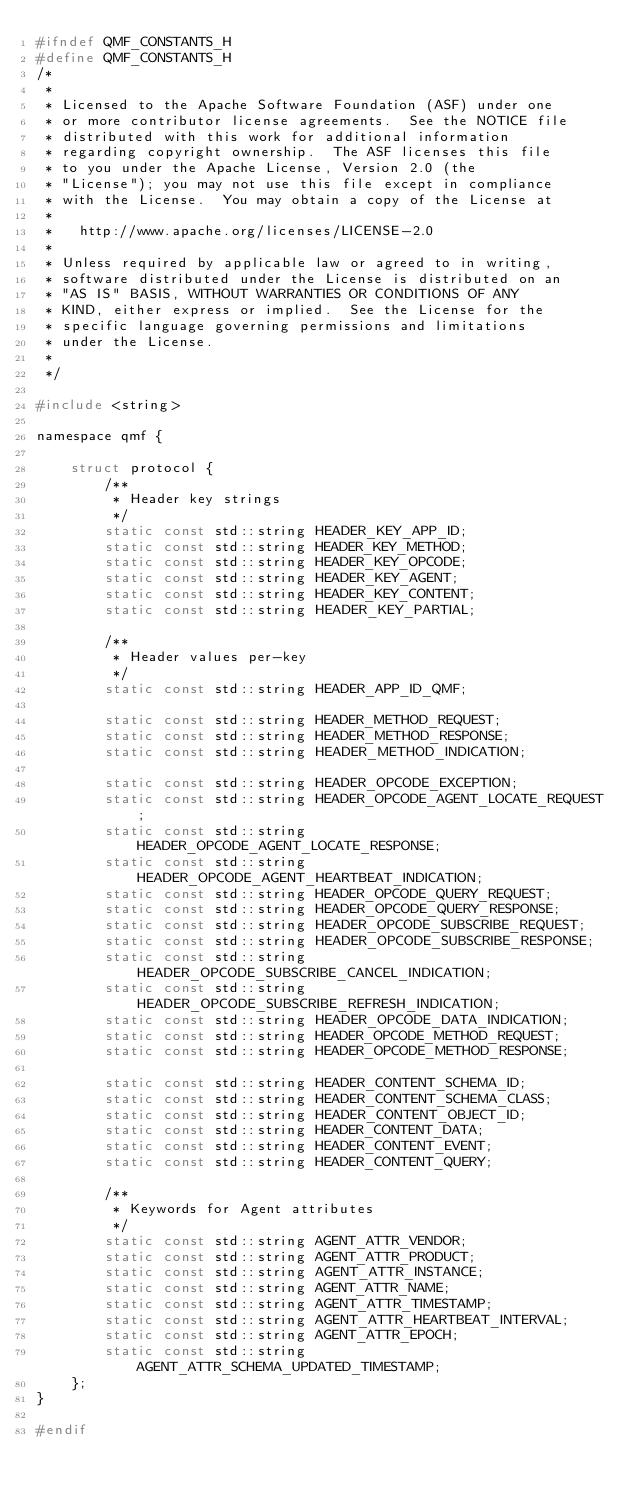<code> <loc_0><loc_0><loc_500><loc_500><_C_>#ifndef QMF_CONSTANTS_H
#define QMF_CONSTANTS_H
/*
 *
 * Licensed to the Apache Software Foundation (ASF) under one
 * or more contributor license agreements.  See the NOTICE file
 * distributed with this work for additional information
 * regarding copyright ownership.  The ASF licenses this file
 * to you under the Apache License, Version 2.0 (the
 * "License"); you may not use this file except in compliance
 * with the License.  You may obtain a copy of the License at
 * 
 *   http://www.apache.org/licenses/LICENSE-2.0
 * 
 * Unless required by applicable law or agreed to in writing,
 * software distributed under the License is distributed on an
 * "AS IS" BASIS, WITHOUT WARRANTIES OR CONDITIONS OF ANY
 * KIND, either express or implied.  See the License for the
 * specific language governing permissions and limitations
 * under the License.
 *
 */

#include <string>

namespace qmf {

    struct protocol {
        /**
         * Header key strings
         */
        static const std::string HEADER_KEY_APP_ID;
        static const std::string HEADER_KEY_METHOD;
        static const std::string HEADER_KEY_OPCODE;
        static const std::string HEADER_KEY_AGENT;
        static const std::string HEADER_KEY_CONTENT;
        static const std::string HEADER_KEY_PARTIAL;

        /**
         * Header values per-key
         */
        static const std::string HEADER_APP_ID_QMF;

        static const std::string HEADER_METHOD_REQUEST;
        static const std::string HEADER_METHOD_RESPONSE;
        static const std::string HEADER_METHOD_INDICATION;

        static const std::string HEADER_OPCODE_EXCEPTION;
        static const std::string HEADER_OPCODE_AGENT_LOCATE_REQUEST;
        static const std::string HEADER_OPCODE_AGENT_LOCATE_RESPONSE;
        static const std::string HEADER_OPCODE_AGENT_HEARTBEAT_INDICATION;
        static const std::string HEADER_OPCODE_QUERY_REQUEST;
        static const std::string HEADER_OPCODE_QUERY_RESPONSE;
        static const std::string HEADER_OPCODE_SUBSCRIBE_REQUEST;
        static const std::string HEADER_OPCODE_SUBSCRIBE_RESPONSE;
        static const std::string HEADER_OPCODE_SUBSCRIBE_CANCEL_INDICATION;
        static const std::string HEADER_OPCODE_SUBSCRIBE_REFRESH_INDICATION;
        static const std::string HEADER_OPCODE_DATA_INDICATION;
        static const std::string HEADER_OPCODE_METHOD_REQUEST;
        static const std::string HEADER_OPCODE_METHOD_RESPONSE;

        static const std::string HEADER_CONTENT_SCHEMA_ID;
        static const std::string HEADER_CONTENT_SCHEMA_CLASS;
        static const std::string HEADER_CONTENT_OBJECT_ID;
        static const std::string HEADER_CONTENT_DATA;
        static const std::string HEADER_CONTENT_EVENT;
        static const std::string HEADER_CONTENT_QUERY;

        /**
         * Keywords for Agent attributes
         */
        static const std::string AGENT_ATTR_VENDOR;
        static const std::string AGENT_ATTR_PRODUCT;
        static const std::string AGENT_ATTR_INSTANCE;
        static const std::string AGENT_ATTR_NAME;
        static const std::string AGENT_ATTR_TIMESTAMP;
        static const std::string AGENT_ATTR_HEARTBEAT_INTERVAL;
        static const std::string AGENT_ATTR_EPOCH;
        static const std::string AGENT_ATTR_SCHEMA_UPDATED_TIMESTAMP;
    };
}

#endif
</code> 